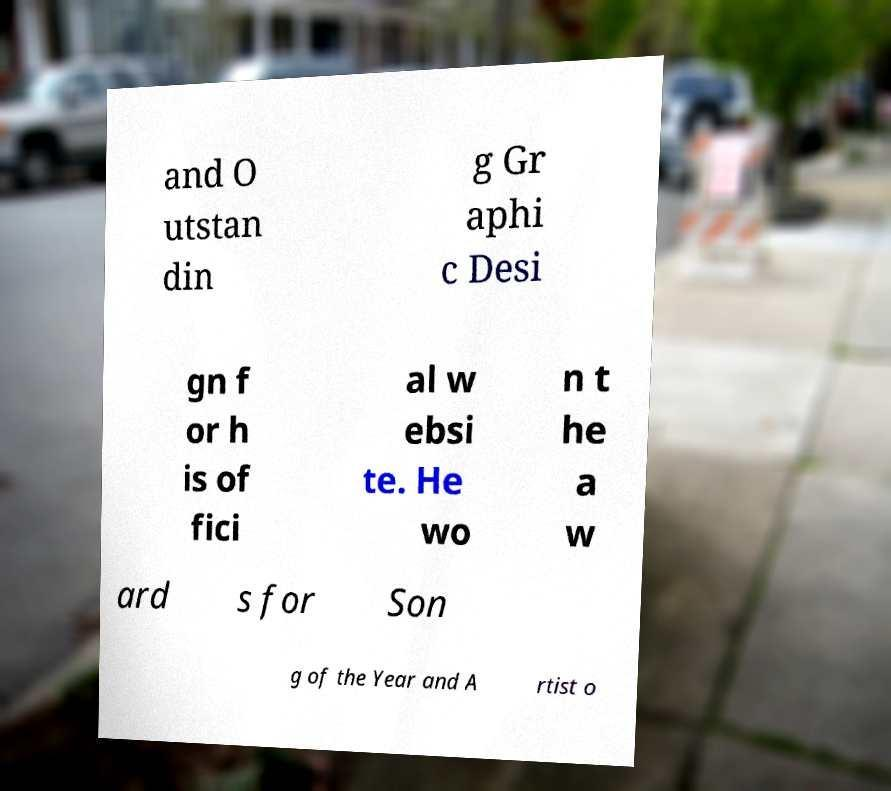What messages or text are displayed in this image? I need them in a readable, typed format. and O utstan din g Gr aphi c Desi gn f or h is of fici al w ebsi te. He wo n t he a w ard s for Son g of the Year and A rtist o 